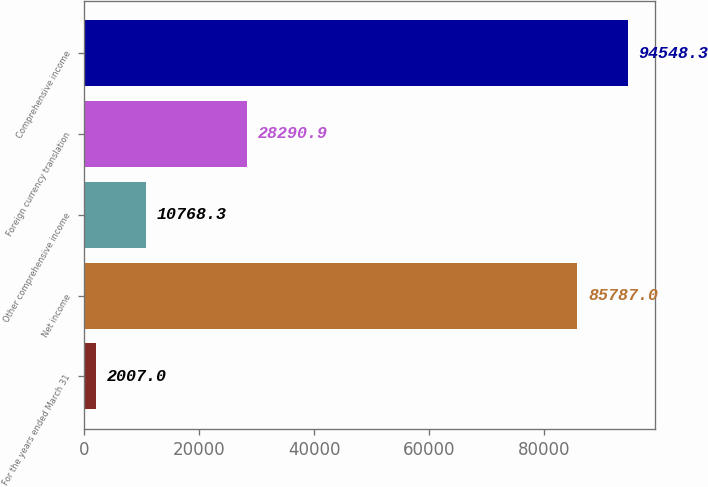<chart> <loc_0><loc_0><loc_500><loc_500><bar_chart><fcel>For the years ended March 31<fcel>Net income<fcel>Other comprehensive income<fcel>Foreign currency translation<fcel>Comprehensive income<nl><fcel>2007<fcel>85787<fcel>10768.3<fcel>28290.9<fcel>94548.3<nl></chart> 